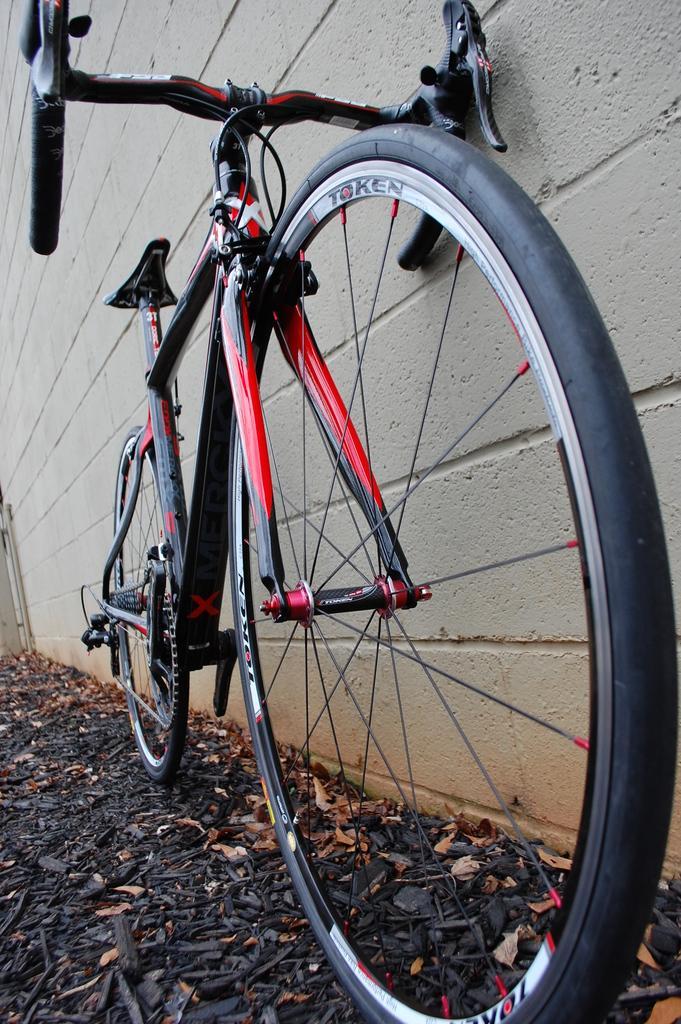Could you give a brief overview of what you see in this image? In this image we can see a bicycle parked near the wall. Here we can see the dry leaves on the ground. 